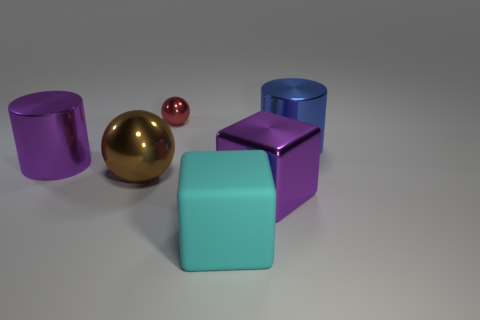Is there any other thing that has the same size as the red object?
Give a very brief answer. No. Is there a red object that has the same size as the cyan rubber object?
Offer a very short reply. No. What is the shape of the red object?
Your answer should be very brief. Sphere. Are there more purple metal things that are in front of the tiny metallic sphere than metallic objects in front of the metallic block?
Keep it short and to the point. Yes. Do the big cylinder in front of the blue metal cylinder and the large shiny object in front of the big metal ball have the same color?
Keep it short and to the point. Yes. The cyan thing that is the same size as the brown thing is what shape?
Your answer should be compact. Cube. Are there any large purple shiny things that have the same shape as the big blue thing?
Make the answer very short. Yes. Are the large purple thing that is left of the purple metallic cube and the block that is in front of the purple metallic cube made of the same material?
Ensure brevity in your answer.  No. The large object that is the same color as the metal block is what shape?
Offer a terse response. Cylinder. How many brown balls are made of the same material as the red ball?
Provide a succinct answer. 1. 